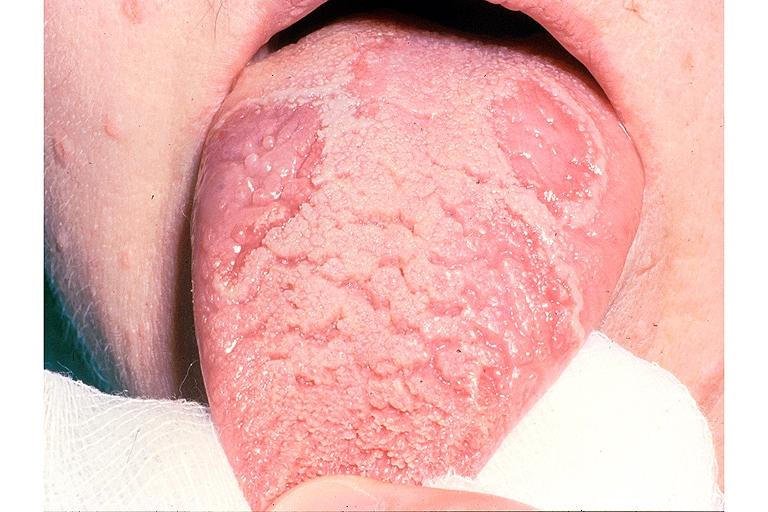s oral present?
Answer the question using a single word or phrase. Yes 